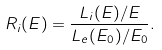Convert formula to latex. <formula><loc_0><loc_0><loc_500><loc_500>R _ { i } ( E ) = \frac { L _ { i } ( E ) / E } { L _ { e } ( E _ { 0 } ) / E _ { 0 } } .</formula> 